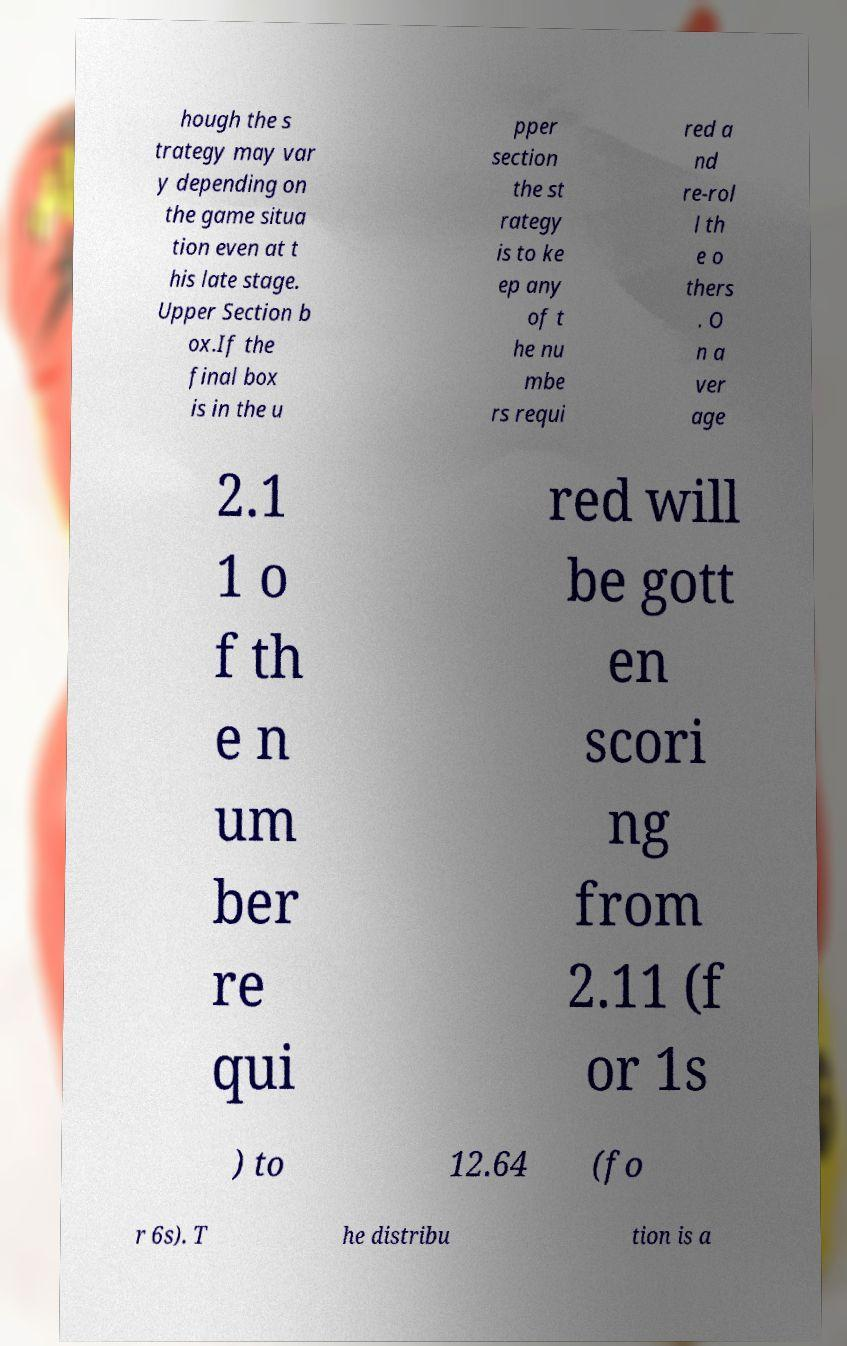Could you extract and type out the text from this image? hough the s trategy may var y depending on the game situa tion even at t his late stage. Upper Section b ox.If the final box is in the u pper section the st rategy is to ke ep any of t he nu mbe rs requi red a nd re-rol l th e o thers . O n a ver age 2.1 1 o f th e n um ber re qui red will be gott en scori ng from 2.11 (f or 1s ) to 12.64 (fo r 6s). T he distribu tion is a 